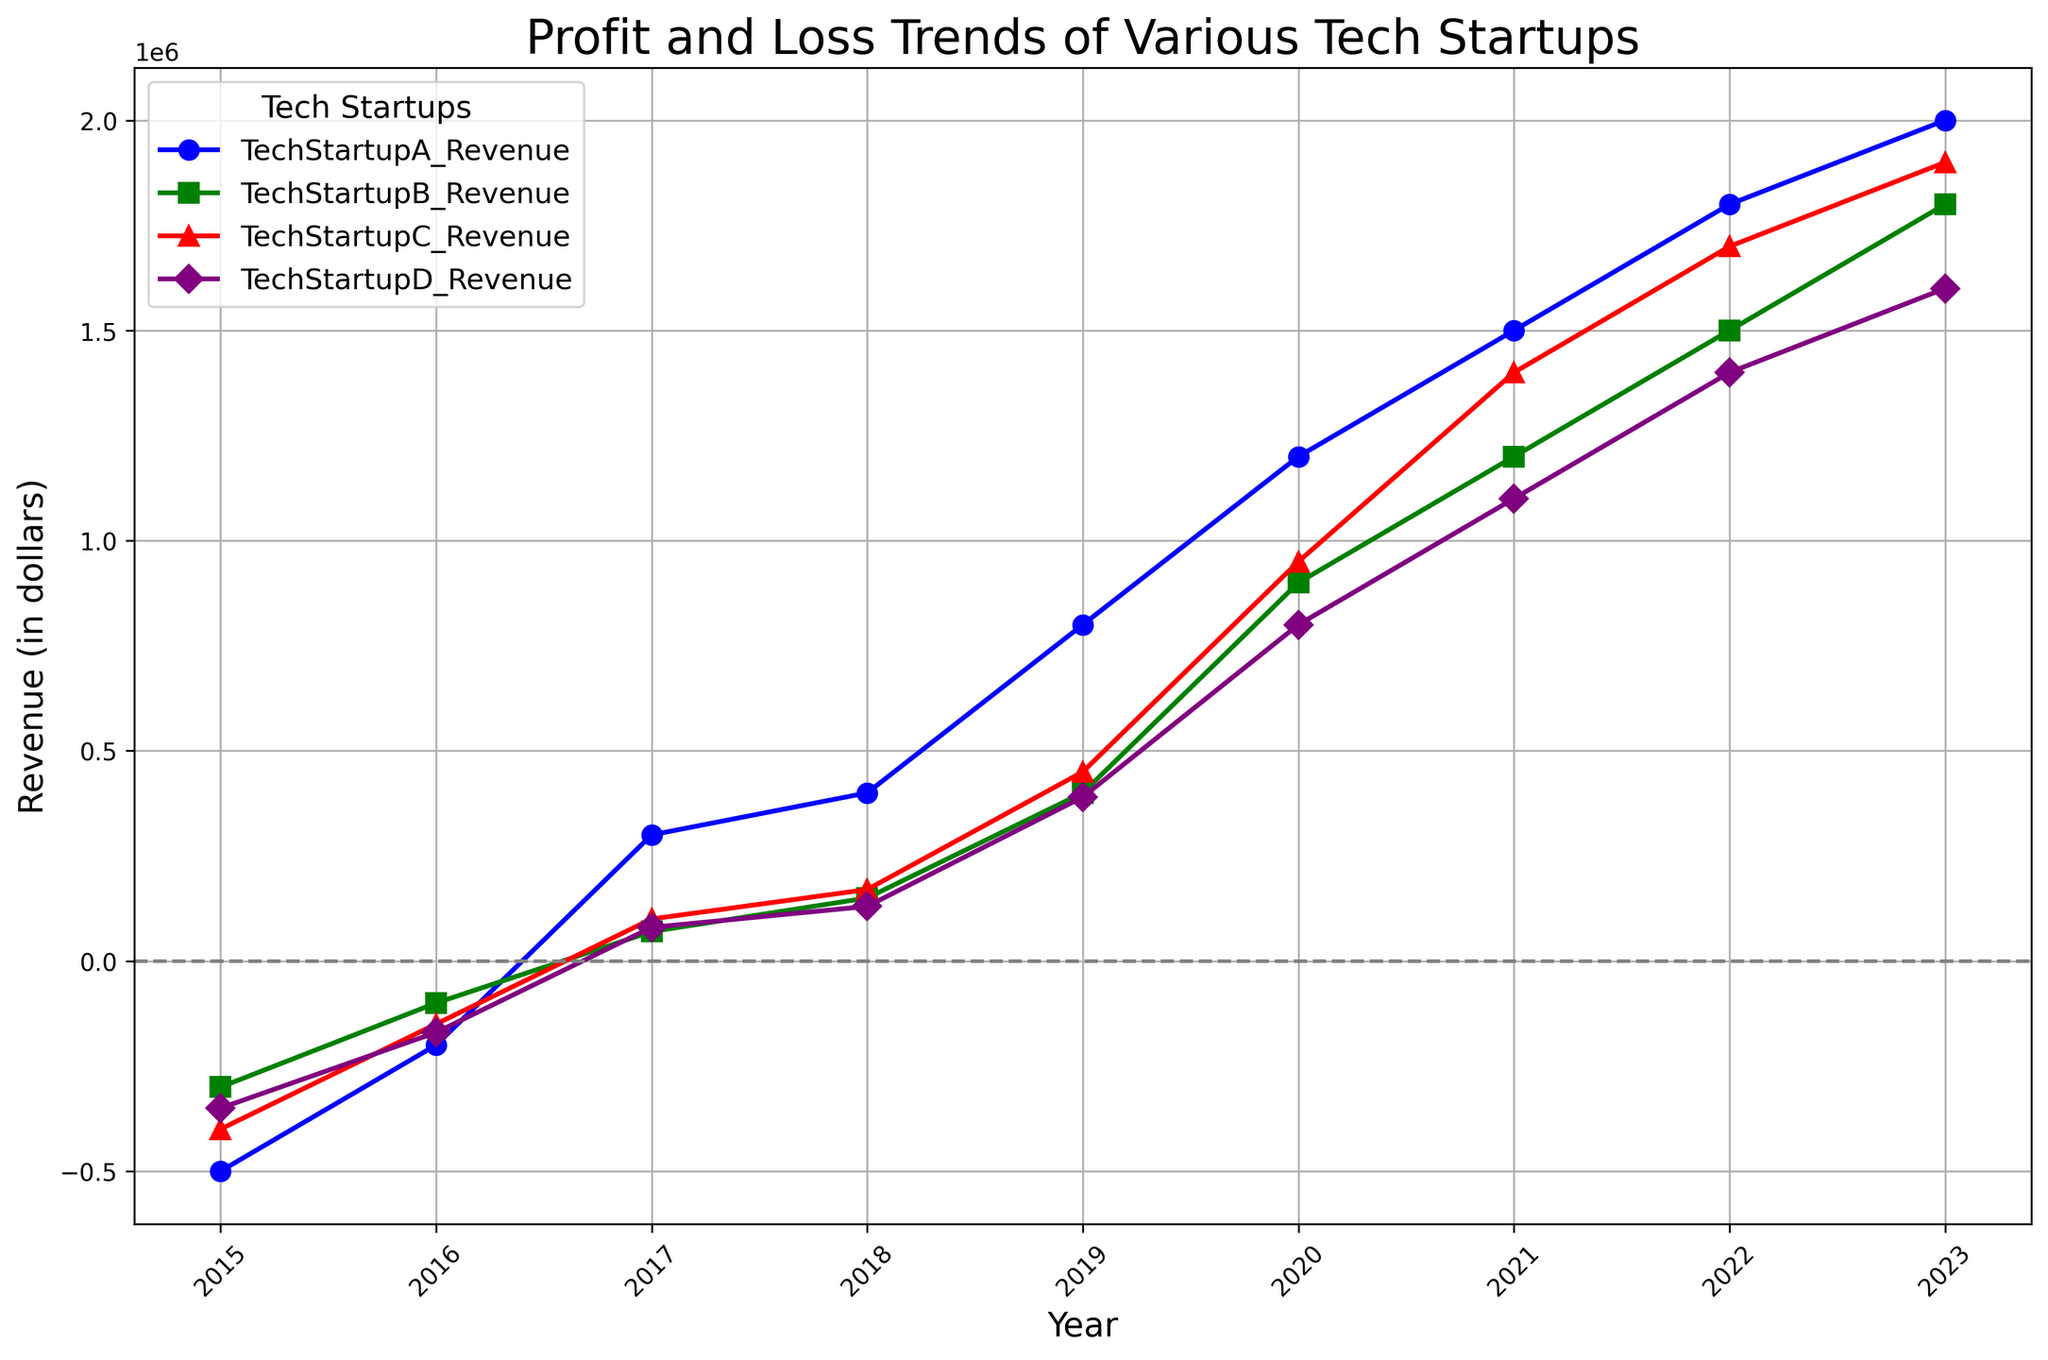Which tech startup had the highest revenue in 2022? To determine this, look at the revenue values for all tech startups in 2022. TechStartupA had 1,800,000, TechStartupB had 1,500,000, TechStartupC had 1,700,000, and TechStartupD had 1,400,000. The highest revenue among these is 1,800,000, belonging to TechStartupA.
Answer: TechStartupA Which tech startup recovered from negative revenue to positive revenue the earliest? Observe the years each startup’s revenue first becomes positive. TechStartupA and TechStartupB both achieve positive revenue in 2017. Similarly, TechStartupC and TechStartupD also move to positive values in 2017. Thus, all four startups recovered in the same year.
Answer: 2017 By how much did TechStartupA's revenue increase from 2016 to 2017? Find the difference between TechStartupA's revenue in 2017 (300000) and 2016 (-200000). Calculate the increase: 300000 - (-200000) = 500000.
Answer: 500000 Which tech startup had the smallest revenue in 2019, and what was it? Check the revenue values for all tech startups in 2019. TechStartupA had 800,000, TechStartupB had 400,000, TechStartupC had 450,000, and TechStartupD had 390,000. The smallest revenue is 390,000, belonging to TechStartupD.
Answer: TechStartupD; 390,000 Which tech startup showed the most consistent revenue growth from 2015 to 2023? Consistent growth implies a steadily increasing revenue trend without large fluctuations. TechStartupA, TechStartupB, TechStartupC, and TechStartupD all show a generally increasing trend. However, TechStartupA shows the smoothest and most pronounced upward trend year over year.
Answer: TechStartupA How many years did it take for TechStartupB to reach positive revenue since 2015? Look at TechStartupB's revenue values from 2015 onwards. TechStartupB had negative revenue in 2015 and 2016 but became positive in 2017. Therefore, it took 2017 - 2015 = 2 years.
Answer: 2 years What is the combined revenue of TechStartupC and TechStartupD in 2020? Add TechStartupC's revenue (950,000) and TechStartupD's revenue (800,000) in 2020. The combined revenue is 950,000 + 800,000 = 1,750,000.
Answer: 1,750,000 Which year saw the biggest growth in revenue for TechStartupD? To find this, calculate the year-to-year increase in revenue for TechStartupD. The biggest increase is from 2019 to 2020, where the revenue jumped from 390,000 to 800,000, an increase of 410,000.
Answer: 2019 to 2020 Were there any years where all tech startups had negative revenue? If so, which years? Refer to the data and look for years where all startups had negative revenue. In 2015, TechStartupA, TechStartupB, TechStartupC, and TechStartupD all had negative revenues. No other year features entirely negative revenues across all startups.
Answer: 2015 